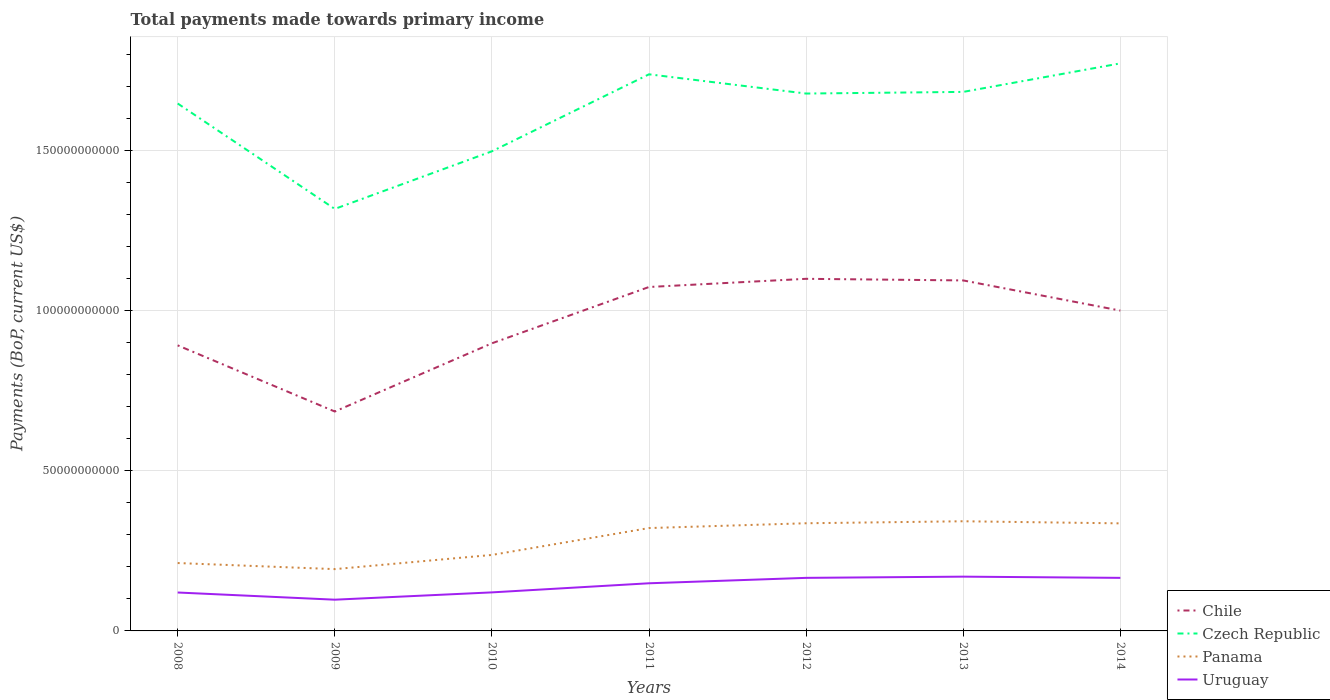How many different coloured lines are there?
Ensure brevity in your answer.  4. Is the number of lines equal to the number of legend labels?
Provide a short and direct response. Yes. Across all years, what is the maximum total payments made towards primary income in Czech Republic?
Keep it short and to the point. 1.32e+11. In which year was the total payments made towards primary income in Czech Republic maximum?
Your response must be concise. 2009. What is the total total payments made towards primary income in Panama in the graph?
Give a very brief answer. -2.53e+09. What is the difference between the highest and the second highest total payments made towards primary income in Chile?
Provide a short and direct response. 4.15e+1. How many lines are there?
Keep it short and to the point. 4. How many years are there in the graph?
Provide a short and direct response. 7. Does the graph contain any zero values?
Ensure brevity in your answer.  No. Where does the legend appear in the graph?
Give a very brief answer. Bottom right. What is the title of the graph?
Your answer should be compact. Total payments made towards primary income. Does "Bahrain" appear as one of the legend labels in the graph?
Give a very brief answer. No. What is the label or title of the Y-axis?
Your response must be concise. Payments (BoP, current US$). What is the Payments (BoP, current US$) in Chile in 2008?
Offer a terse response. 8.92e+1. What is the Payments (BoP, current US$) in Czech Republic in 2008?
Keep it short and to the point. 1.65e+11. What is the Payments (BoP, current US$) in Panama in 2008?
Keep it short and to the point. 2.12e+1. What is the Payments (BoP, current US$) in Uruguay in 2008?
Provide a succinct answer. 1.20e+1. What is the Payments (BoP, current US$) in Chile in 2009?
Provide a short and direct response. 6.86e+1. What is the Payments (BoP, current US$) in Czech Republic in 2009?
Offer a terse response. 1.32e+11. What is the Payments (BoP, current US$) in Panama in 2009?
Offer a very short reply. 1.93e+1. What is the Payments (BoP, current US$) of Uruguay in 2009?
Give a very brief answer. 9.76e+09. What is the Payments (BoP, current US$) of Chile in 2010?
Your answer should be compact. 8.99e+1. What is the Payments (BoP, current US$) of Czech Republic in 2010?
Your answer should be compact. 1.50e+11. What is the Payments (BoP, current US$) in Panama in 2010?
Your response must be concise. 2.37e+1. What is the Payments (BoP, current US$) in Uruguay in 2010?
Provide a short and direct response. 1.20e+1. What is the Payments (BoP, current US$) in Chile in 2011?
Provide a short and direct response. 1.07e+11. What is the Payments (BoP, current US$) of Czech Republic in 2011?
Offer a very short reply. 1.74e+11. What is the Payments (BoP, current US$) in Panama in 2011?
Offer a very short reply. 3.21e+1. What is the Payments (BoP, current US$) of Uruguay in 2011?
Provide a short and direct response. 1.49e+1. What is the Payments (BoP, current US$) of Chile in 2012?
Provide a succinct answer. 1.10e+11. What is the Payments (BoP, current US$) of Czech Republic in 2012?
Give a very brief answer. 1.68e+11. What is the Payments (BoP, current US$) in Panama in 2012?
Offer a very short reply. 3.36e+1. What is the Payments (BoP, current US$) in Uruguay in 2012?
Offer a terse response. 1.66e+1. What is the Payments (BoP, current US$) in Chile in 2013?
Make the answer very short. 1.10e+11. What is the Payments (BoP, current US$) in Czech Republic in 2013?
Provide a succinct answer. 1.68e+11. What is the Payments (BoP, current US$) of Panama in 2013?
Make the answer very short. 3.43e+1. What is the Payments (BoP, current US$) in Uruguay in 2013?
Ensure brevity in your answer.  1.70e+1. What is the Payments (BoP, current US$) of Chile in 2014?
Keep it short and to the point. 1.00e+11. What is the Payments (BoP, current US$) of Czech Republic in 2014?
Your answer should be very brief. 1.77e+11. What is the Payments (BoP, current US$) in Panama in 2014?
Your answer should be very brief. 3.36e+1. What is the Payments (BoP, current US$) in Uruguay in 2014?
Your response must be concise. 1.66e+1. Across all years, what is the maximum Payments (BoP, current US$) of Chile?
Provide a succinct answer. 1.10e+11. Across all years, what is the maximum Payments (BoP, current US$) in Czech Republic?
Make the answer very short. 1.77e+11. Across all years, what is the maximum Payments (BoP, current US$) of Panama?
Your response must be concise. 3.43e+1. Across all years, what is the maximum Payments (BoP, current US$) of Uruguay?
Your response must be concise. 1.70e+1. Across all years, what is the minimum Payments (BoP, current US$) in Chile?
Give a very brief answer. 6.86e+1. Across all years, what is the minimum Payments (BoP, current US$) of Czech Republic?
Provide a short and direct response. 1.32e+11. Across all years, what is the minimum Payments (BoP, current US$) in Panama?
Your response must be concise. 1.93e+1. Across all years, what is the minimum Payments (BoP, current US$) in Uruguay?
Keep it short and to the point. 9.76e+09. What is the total Payments (BoP, current US$) in Chile in the graph?
Make the answer very short. 6.75e+11. What is the total Payments (BoP, current US$) of Czech Republic in the graph?
Provide a succinct answer. 1.13e+12. What is the total Payments (BoP, current US$) in Panama in the graph?
Your response must be concise. 1.98e+11. What is the total Payments (BoP, current US$) in Uruguay in the graph?
Your answer should be compact. 9.88e+1. What is the difference between the Payments (BoP, current US$) in Chile in 2008 and that in 2009?
Keep it short and to the point. 2.07e+1. What is the difference between the Payments (BoP, current US$) of Czech Republic in 2008 and that in 2009?
Your answer should be compact. 3.29e+1. What is the difference between the Payments (BoP, current US$) of Panama in 2008 and that in 2009?
Keep it short and to the point. 1.90e+09. What is the difference between the Payments (BoP, current US$) in Uruguay in 2008 and that in 2009?
Your answer should be compact. 2.24e+09. What is the difference between the Payments (BoP, current US$) in Chile in 2008 and that in 2010?
Offer a terse response. -6.36e+08. What is the difference between the Payments (BoP, current US$) in Czech Republic in 2008 and that in 2010?
Give a very brief answer. 1.49e+1. What is the difference between the Payments (BoP, current US$) in Panama in 2008 and that in 2010?
Keep it short and to the point. -2.53e+09. What is the difference between the Payments (BoP, current US$) of Uruguay in 2008 and that in 2010?
Your answer should be compact. -3.72e+07. What is the difference between the Payments (BoP, current US$) of Chile in 2008 and that in 2011?
Your response must be concise. -1.82e+1. What is the difference between the Payments (BoP, current US$) of Czech Republic in 2008 and that in 2011?
Provide a short and direct response. -9.12e+09. What is the difference between the Payments (BoP, current US$) in Panama in 2008 and that in 2011?
Offer a terse response. -1.09e+1. What is the difference between the Payments (BoP, current US$) of Uruguay in 2008 and that in 2011?
Give a very brief answer. -2.88e+09. What is the difference between the Payments (BoP, current US$) in Chile in 2008 and that in 2012?
Offer a very short reply. -2.08e+1. What is the difference between the Payments (BoP, current US$) of Czech Republic in 2008 and that in 2012?
Your answer should be very brief. -3.11e+09. What is the difference between the Payments (BoP, current US$) of Panama in 2008 and that in 2012?
Offer a terse response. -1.24e+1. What is the difference between the Payments (BoP, current US$) of Uruguay in 2008 and that in 2012?
Ensure brevity in your answer.  -4.57e+09. What is the difference between the Payments (BoP, current US$) of Chile in 2008 and that in 2013?
Your answer should be compact. -2.03e+1. What is the difference between the Payments (BoP, current US$) in Czech Republic in 2008 and that in 2013?
Your response must be concise. -3.62e+09. What is the difference between the Payments (BoP, current US$) of Panama in 2008 and that in 2013?
Provide a short and direct response. -1.31e+1. What is the difference between the Payments (BoP, current US$) of Uruguay in 2008 and that in 2013?
Keep it short and to the point. -4.95e+09. What is the difference between the Payments (BoP, current US$) of Chile in 2008 and that in 2014?
Give a very brief answer. -1.09e+1. What is the difference between the Payments (BoP, current US$) in Czech Republic in 2008 and that in 2014?
Provide a succinct answer. -1.25e+1. What is the difference between the Payments (BoP, current US$) of Panama in 2008 and that in 2014?
Provide a short and direct response. -1.24e+1. What is the difference between the Payments (BoP, current US$) of Uruguay in 2008 and that in 2014?
Offer a terse response. -4.57e+09. What is the difference between the Payments (BoP, current US$) of Chile in 2009 and that in 2010?
Provide a short and direct response. -2.13e+1. What is the difference between the Payments (BoP, current US$) in Czech Republic in 2009 and that in 2010?
Make the answer very short. -1.80e+1. What is the difference between the Payments (BoP, current US$) in Panama in 2009 and that in 2010?
Provide a succinct answer. -4.43e+09. What is the difference between the Payments (BoP, current US$) of Uruguay in 2009 and that in 2010?
Give a very brief answer. -2.28e+09. What is the difference between the Payments (BoP, current US$) of Chile in 2009 and that in 2011?
Provide a short and direct response. -3.89e+1. What is the difference between the Payments (BoP, current US$) of Czech Republic in 2009 and that in 2011?
Provide a succinct answer. -4.21e+1. What is the difference between the Payments (BoP, current US$) of Panama in 2009 and that in 2011?
Give a very brief answer. -1.28e+1. What is the difference between the Payments (BoP, current US$) in Uruguay in 2009 and that in 2011?
Provide a short and direct response. -5.13e+09. What is the difference between the Payments (BoP, current US$) of Chile in 2009 and that in 2012?
Provide a succinct answer. -4.15e+1. What is the difference between the Payments (BoP, current US$) in Czech Republic in 2009 and that in 2012?
Keep it short and to the point. -3.61e+1. What is the difference between the Payments (BoP, current US$) in Panama in 2009 and that in 2012?
Give a very brief answer. -1.43e+1. What is the difference between the Payments (BoP, current US$) of Uruguay in 2009 and that in 2012?
Your response must be concise. -6.82e+09. What is the difference between the Payments (BoP, current US$) of Chile in 2009 and that in 2013?
Give a very brief answer. -4.10e+1. What is the difference between the Payments (BoP, current US$) in Czech Republic in 2009 and that in 2013?
Provide a short and direct response. -3.66e+1. What is the difference between the Payments (BoP, current US$) in Panama in 2009 and that in 2013?
Offer a terse response. -1.50e+1. What is the difference between the Payments (BoP, current US$) in Uruguay in 2009 and that in 2013?
Your response must be concise. -7.20e+09. What is the difference between the Payments (BoP, current US$) in Chile in 2009 and that in 2014?
Keep it short and to the point. -3.15e+1. What is the difference between the Payments (BoP, current US$) in Czech Republic in 2009 and that in 2014?
Provide a short and direct response. -4.55e+1. What is the difference between the Payments (BoP, current US$) of Panama in 2009 and that in 2014?
Offer a very short reply. -1.43e+1. What is the difference between the Payments (BoP, current US$) in Uruguay in 2009 and that in 2014?
Offer a terse response. -6.82e+09. What is the difference between the Payments (BoP, current US$) of Chile in 2010 and that in 2011?
Your answer should be compact. -1.76e+1. What is the difference between the Payments (BoP, current US$) in Czech Republic in 2010 and that in 2011?
Offer a terse response. -2.41e+1. What is the difference between the Payments (BoP, current US$) in Panama in 2010 and that in 2011?
Make the answer very short. -8.40e+09. What is the difference between the Payments (BoP, current US$) in Uruguay in 2010 and that in 2011?
Give a very brief answer. -2.85e+09. What is the difference between the Payments (BoP, current US$) in Chile in 2010 and that in 2012?
Ensure brevity in your answer.  -2.02e+1. What is the difference between the Payments (BoP, current US$) in Czech Republic in 2010 and that in 2012?
Make the answer very short. -1.81e+1. What is the difference between the Payments (BoP, current US$) of Panama in 2010 and that in 2012?
Ensure brevity in your answer.  -9.90e+09. What is the difference between the Payments (BoP, current US$) in Uruguay in 2010 and that in 2012?
Offer a very short reply. -4.54e+09. What is the difference between the Payments (BoP, current US$) in Chile in 2010 and that in 2013?
Your answer should be compact. -1.97e+1. What is the difference between the Payments (BoP, current US$) in Czech Republic in 2010 and that in 2013?
Provide a short and direct response. -1.86e+1. What is the difference between the Payments (BoP, current US$) of Panama in 2010 and that in 2013?
Offer a very short reply. -1.05e+1. What is the difference between the Payments (BoP, current US$) of Uruguay in 2010 and that in 2013?
Your answer should be very brief. -4.92e+09. What is the difference between the Payments (BoP, current US$) of Chile in 2010 and that in 2014?
Your answer should be compact. -1.02e+1. What is the difference between the Payments (BoP, current US$) of Czech Republic in 2010 and that in 2014?
Give a very brief answer. -2.75e+1. What is the difference between the Payments (BoP, current US$) of Panama in 2010 and that in 2014?
Offer a terse response. -9.87e+09. What is the difference between the Payments (BoP, current US$) in Uruguay in 2010 and that in 2014?
Ensure brevity in your answer.  -4.54e+09. What is the difference between the Payments (BoP, current US$) of Chile in 2011 and that in 2012?
Make the answer very short. -2.56e+09. What is the difference between the Payments (BoP, current US$) of Czech Republic in 2011 and that in 2012?
Keep it short and to the point. 6.01e+09. What is the difference between the Payments (BoP, current US$) in Panama in 2011 and that in 2012?
Provide a short and direct response. -1.50e+09. What is the difference between the Payments (BoP, current US$) in Uruguay in 2011 and that in 2012?
Your response must be concise. -1.69e+09. What is the difference between the Payments (BoP, current US$) in Chile in 2011 and that in 2013?
Give a very brief answer. -2.05e+09. What is the difference between the Payments (BoP, current US$) of Czech Republic in 2011 and that in 2013?
Keep it short and to the point. 5.50e+09. What is the difference between the Payments (BoP, current US$) in Panama in 2011 and that in 2013?
Your answer should be compact. -2.12e+09. What is the difference between the Payments (BoP, current US$) in Uruguay in 2011 and that in 2013?
Offer a terse response. -2.07e+09. What is the difference between the Payments (BoP, current US$) of Chile in 2011 and that in 2014?
Ensure brevity in your answer.  7.37e+09. What is the difference between the Payments (BoP, current US$) of Czech Republic in 2011 and that in 2014?
Your answer should be compact. -3.41e+09. What is the difference between the Payments (BoP, current US$) in Panama in 2011 and that in 2014?
Your answer should be very brief. -1.47e+09. What is the difference between the Payments (BoP, current US$) in Uruguay in 2011 and that in 2014?
Ensure brevity in your answer.  -1.69e+09. What is the difference between the Payments (BoP, current US$) of Chile in 2012 and that in 2013?
Make the answer very short. 5.05e+08. What is the difference between the Payments (BoP, current US$) of Czech Republic in 2012 and that in 2013?
Keep it short and to the point. -5.15e+08. What is the difference between the Payments (BoP, current US$) in Panama in 2012 and that in 2013?
Ensure brevity in your answer.  -6.23e+08. What is the difference between the Payments (BoP, current US$) of Uruguay in 2012 and that in 2013?
Offer a terse response. -3.80e+08. What is the difference between the Payments (BoP, current US$) in Chile in 2012 and that in 2014?
Give a very brief answer. 9.93e+09. What is the difference between the Payments (BoP, current US$) of Czech Republic in 2012 and that in 2014?
Provide a succinct answer. -9.42e+09. What is the difference between the Payments (BoP, current US$) in Panama in 2012 and that in 2014?
Make the answer very short. 3.20e+07. What is the difference between the Payments (BoP, current US$) in Uruguay in 2012 and that in 2014?
Keep it short and to the point. -4.09e+05. What is the difference between the Payments (BoP, current US$) of Chile in 2013 and that in 2014?
Give a very brief answer. 9.43e+09. What is the difference between the Payments (BoP, current US$) in Czech Republic in 2013 and that in 2014?
Ensure brevity in your answer.  -8.91e+09. What is the difference between the Payments (BoP, current US$) of Panama in 2013 and that in 2014?
Your response must be concise. 6.55e+08. What is the difference between the Payments (BoP, current US$) in Uruguay in 2013 and that in 2014?
Keep it short and to the point. 3.80e+08. What is the difference between the Payments (BoP, current US$) in Chile in 2008 and the Payments (BoP, current US$) in Czech Republic in 2009?
Provide a succinct answer. -4.26e+1. What is the difference between the Payments (BoP, current US$) in Chile in 2008 and the Payments (BoP, current US$) in Panama in 2009?
Ensure brevity in your answer.  6.99e+1. What is the difference between the Payments (BoP, current US$) of Chile in 2008 and the Payments (BoP, current US$) of Uruguay in 2009?
Ensure brevity in your answer.  7.95e+1. What is the difference between the Payments (BoP, current US$) of Czech Republic in 2008 and the Payments (BoP, current US$) of Panama in 2009?
Ensure brevity in your answer.  1.46e+11. What is the difference between the Payments (BoP, current US$) of Czech Republic in 2008 and the Payments (BoP, current US$) of Uruguay in 2009?
Provide a short and direct response. 1.55e+11. What is the difference between the Payments (BoP, current US$) of Panama in 2008 and the Payments (BoP, current US$) of Uruguay in 2009?
Your answer should be very brief. 1.15e+1. What is the difference between the Payments (BoP, current US$) of Chile in 2008 and the Payments (BoP, current US$) of Czech Republic in 2010?
Your response must be concise. -6.06e+1. What is the difference between the Payments (BoP, current US$) of Chile in 2008 and the Payments (BoP, current US$) of Panama in 2010?
Your response must be concise. 6.55e+1. What is the difference between the Payments (BoP, current US$) in Chile in 2008 and the Payments (BoP, current US$) in Uruguay in 2010?
Offer a very short reply. 7.72e+1. What is the difference between the Payments (BoP, current US$) in Czech Republic in 2008 and the Payments (BoP, current US$) in Panama in 2010?
Keep it short and to the point. 1.41e+11. What is the difference between the Payments (BoP, current US$) of Czech Republic in 2008 and the Payments (BoP, current US$) of Uruguay in 2010?
Give a very brief answer. 1.53e+11. What is the difference between the Payments (BoP, current US$) of Panama in 2008 and the Payments (BoP, current US$) of Uruguay in 2010?
Provide a short and direct response. 9.17e+09. What is the difference between the Payments (BoP, current US$) of Chile in 2008 and the Payments (BoP, current US$) of Czech Republic in 2011?
Offer a very short reply. -8.47e+1. What is the difference between the Payments (BoP, current US$) in Chile in 2008 and the Payments (BoP, current US$) in Panama in 2011?
Give a very brief answer. 5.71e+1. What is the difference between the Payments (BoP, current US$) in Chile in 2008 and the Payments (BoP, current US$) in Uruguay in 2011?
Your answer should be compact. 7.44e+1. What is the difference between the Payments (BoP, current US$) of Czech Republic in 2008 and the Payments (BoP, current US$) of Panama in 2011?
Offer a terse response. 1.33e+11. What is the difference between the Payments (BoP, current US$) in Czech Republic in 2008 and the Payments (BoP, current US$) in Uruguay in 2011?
Offer a terse response. 1.50e+11. What is the difference between the Payments (BoP, current US$) of Panama in 2008 and the Payments (BoP, current US$) of Uruguay in 2011?
Ensure brevity in your answer.  6.33e+09. What is the difference between the Payments (BoP, current US$) in Chile in 2008 and the Payments (BoP, current US$) in Czech Republic in 2012?
Ensure brevity in your answer.  -7.87e+1. What is the difference between the Payments (BoP, current US$) of Chile in 2008 and the Payments (BoP, current US$) of Panama in 2012?
Offer a very short reply. 5.56e+1. What is the difference between the Payments (BoP, current US$) in Chile in 2008 and the Payments (BoP, current US$) in Uruguay in 2012?
Your answer should be very brief. 7.27e+1. What is the difference between the Payments (BoP, current US$) in Czech Republic in 2008 and the Payments (BoP, current US$) in Panama in 2012?
Your response must be concise. 1.31e+11. What is the difference between the Payments (BoP, current US$) in Czech Republic in 2008 and the Payments (BoP, current US$) in Uruguay in 2012?
Give a very brief answer. 1.48e+11. What is the difference between the Payments (BoP, current US$) of Panama in 2008 and the Payments (BoP, current US$) of Uruguay in 2012?
Your answer should be very brief. 4.63e+09. What is the difference between the Payments (BoP, current US$) of Chile in 2008 and the Payments (BoP, current US$) of Czech Republic in 2013?
Your answer should be compact. -7.92e+1. What is the difference between the Payments (BoP, current US$) of Chile in 2008 and the Payments (BoP, current US$) of Panama in 2013?
Your answer should be very brief. 5.50e+1. What is the difference between the Payments (BoP, current US$) in Chile in 2008 and the Payments (BoP, current US$) in Uruguay in 2013?
Offer a very short reply. 7.23e+1. What is the difference between the Payments (BoP, current US$) of Czech Republic in 2008 and the Payments (BoP, current US$) of Panama in 2013?
Ensure brevity in your answer.  1.31e+11. What is the difference between the Payments (BoP, current US$) of Czech Republic in 2008 and the Payments (BoP, current US$) of Uruguay in 2013?
Offer a very short reply. 1.48e+11. What is the difference between the Payments (BoP, current US$) in Panama in 2008 and the Payments (BoP, current US$) in Uruguay in 2013?
Provide a short and direct response. 4.25e+09. What is the difference between the Payments (BoP, current US$) in Chile in 2008 and the Payments (BoP, current US$) in Czech Republic in 2014?
Your response must be concise. -8.81e+1. What is the difference between the Payments (BoP, current US$) in Chile in 2008 and the Payments (BoP, current US$) in Panama in 2014?
Make the answer very short. 5.56e+1. What is the difference between the Payments (BoP, current US$) in Chile in 2008 and the Payments (BoP, current US$) in Uruguay in 2014?
Offer a very short reply. 7.27e+1. What is the difference between the Payments (BoP, current US$) in Czech Republic in 2008 and the Payments (BoP, current US$) in Panama in 2014?
Offer a terse response. 1.31e+11. What is the difference between the Payments (BoP, current US$) of Czech Republic in 2008 and the Payments (BoP, current US$) of Uruguay in 2014?
Ensure brevity in your answer.  1.48e+11. What is the difference between the Payments (BoP, current US$) of Panama in 2008 and the Payments (BoP, current US$) of Uruguay in 2014?
Your response must be concise. 4.63e+09. What is the difference between the Payments (BoP, current US$) of Chile in 2009 and the Payments (BoP, current US$) of Czech Republic in 2010?
Provide a short and direct response. -8.13e+1. What is the difference between the Payments (BoP, current US$) of Chile in 2009 and the Payments (BoP, current US$) of Panama in 2010?
Make the answer very short. 4.48e+1. What is the difference between the Payments (BoP, current US$) in Chile in 2009 and the Payments (BoP, current US$) in Uruguay in 2010?
Provide a succinct answer. 5.65e+1. What is the difference between the Payments (BoP, current US$) in Czech Republic in 2009 and the Payments (BoP, current US$) in Panama in 2010?
Keep it short and to the point. 1.08e+11. What is the difference between the Payments (BoP, current US$) in Czech Republic in 2009 and the Payments (BoP, current US$) in Uruguay in 2010?
Offer a terse response. 1.20e+11. What is the difference between the Payments (BoP, current US$) in Panama in 2009 and the Payments (BoP, current US$) in Uruguay in 2010?
Offer a very short reply. 7.27e+09. What is the difference between the Payments (BoP, current US$) of Chile in 2009 and the Payments (BoP, current US$) of Czech Republic in 2011?
Provide a short and direct response. -1.05e+11. What is the difference between the Payments (BoP, current US$) of Chile in 2009 and the Payments (BoP, current US$) of Panama in 2011?
Your answer should be compact. 3.64e+1. What is the difference between the Payments (BoP, current US$) in Chile in 2009 and the Payments (BoP, current US$) in Uruguay in 2011?
Keep it short and to the point. 5.37e+1. What is the difference between the Payments (BoP, current US$) in Czech Republic in 2009 and the Payments (BoP, current US$) in Panama in 2011?
Offer a very short reply. 9.97e+1. What is the difference between the Payments (BoP, current US$) in Czech Republic in 2009 and the Payments (BoP, current US$) in Uruguay in 2011?
Offer a terse response. 1.17e+11. What is the difference between the Payments (BoP, current US$) of Panama in 2009 and the Payments (BoP, current US$) of Uruguay in 2011?
Offer a terse response. 4.42e+09. What is the difference between the Payments (BoP, current US$) of Chile in 2009 and the Payments (BoP, current US$) of Czech Republic in 2012?
Keep it short and to the point. -9.94e+1. What is the difference between the Payments (BoP, current US$) of Chile in 2009 and the Payments (BoP, current US$) of Panama in 2012?
Your answer should be compact. 3.49e+1. What is the difference between the Payments (BoP, current US$) of Chile in 2009 and the Payments (BoP, current US$) of Uruguay in 2012?
Offer a terse response. 5.20e+1. What is the difference between the Payments (BoP, current US$) in Czech Republic in 2009 and the Payments (BoP, current US$) in Panama in 2012?
Provide a short and direct response. 9.82e+1. What is the difference between the Payments (BoP, current US$) of Czech Republic in 2009 and the Payments (BoP, current US$) of Uruguay in 2012?
Keep it short and to the point. 1.15e+11. What is the difference between the Payments (BoP, current US$) of Panama in 2009 and the Payments (BoP, current US$) of Uruguay in 2012?
Keep it short and to the point. 2.73e+09. What is the difference between the Payments (BoP, current US$) in Chile in 2009 and the Payments (BoP, current US$) in Czech Republic in 2013?
Keep it short and to the point. -9.99e+1. What is the difference between the Payments (BoP, current US$) in Chile in 2009 and the Payments (BoP, current US$) in Panama in 2013?
Your response must be concise. 3.43e+1. What is the difference between the Payments (BoP, current US$) in Chile in 2009 and the Payments (BoP, current US$) in Uruguay in 2013?
Give a very brief answer. 5.16e+1. What is the difference between the Payments (BoP, current US$) of Czech Republic in 2009 and the Payments (BoP, current US$) of Panama in 2013?
Keep it short and to the point. 9.76e+1. What is the difference between the Payments (BoP, current US$) in Czech Republic in 2009 and the Payments (BoP, current US$) in Uruguay in 2013?
Keep it short and to the point. 1.15e+11. What is the difference between the Payments (BoP, current US$) in Panama in 2009 and the Payments (BoP, current US$) in Uruguay in 2013?
Offer a terse response. 2.35e+09. What is the difference between the Payments (BoP, current US$) of Chile in 2009 and the Payments (BoP, current US$) of Czech Republic in 2014?
Make the answer very short. -1.09e+11. What is the difference between the Payments (BoP, current US$) in Chile in 2009 and the Payments (BoP, current US$) in Panama in 2014?
Make the answer very short. 3.50e+1. What is the difference between the Payments (BoP, current US$) in Chile in 2009 and the Payments (BoP, current US$) in Uruguay in 2014?
Provide a short and direct response. 5.20e+1. What is the difference between the Payments (BoP, current US$) in Czech Republic in 2009 and the Payments (BoP, current US$) in Panama in 2014?
Your answer should be compact. 9.83e+1. What is the difference between the Payments (BoP, current US$) of Czech Republic in 2009 and the Payments (BoP, current US$) of Uruguay in 2014?
Your answer should be compact. 1.15e+11. What is the difference between the Payments (BoP, current US$) in Panama in 2009 and the Payments (BoP, current US$) in Uruguay in 2014?
Ensure brevity in your answer.  2.73e+09. What is the difference between the Payments (BoP, current US$) in Chile in 2010 and the Payments (BoP, current US$) in Czech Republic in 2011?
Provide a succinct answer. -8.41e+1. What is the difference between the Payments (BoP, current US$) of Chile in 2010 and the Payments (BoP, current US$) of Panama in 2011?
Provide a succinct answer. 5.77e+1. What is the difference between the Payments (BoP, current US$) in Chile in 2010 and the Payments (BoP, current US$) in Uruguay in 2011?
Ensure brevity in your answer.  7.50e+1. What is the difference between the Payments (BoP, current US$) of Czech Republic in 2010 and the Payments (BoP, current US$) of Panama in 2011?
Make the answer very short. 1.18e+11. What is the difference between the Payments (BoP, current US$) in Czech Republic in 2010 and the Payments (BoP, current US$) in Uruguay in 2011?
Provide a succinct answer. 1.35e+11. What is the difference between the Payments (BoP, current US$) in Panama in 2010 and the Payments (BoP, current US$) in Uruguay in 2011?
Ensure brevity in your answer.  8.86e+09. What is the difference between the Payments (BoP, current US$) in Chile in 2010 and the Payments (BoP, current US$) in Czech Republic in 2012?
Ensure brevity in your answer.  -7.81e+1. What is the difference between the Payments (BoP, current US$) of Chile in 2010 and the Payments (BoP, current US$) of Panama in 2012?
Offer a very short reply. 5.62e+1. What is the difference between the Payments (BoP, current US$) of Chile in 2010 and the Payments (BoP, current US$) of Uruguay in 2012?
Offer a very short reply. 7.33e+1. What is the difference between the Payments (BoP, current US$) in Czech Republic in 2010 and the Payments (BoP, current US$) in Panama in 2012?
Offer a very short reply. 1.16e+11. What is the difference between the Payments (BoP, current US$) of Czech Republic in 2010 and the Payments (BoP, current US$) of Uruguay in 2012?
Keep it short and to the point. 1.33e+11. What is the difference between the Payments (BoP, current US$) of Panama in 2010 and the Payments (BoP, current US$) of Uruguay in 2012?
Keep it short and to the point. 7.17e+09. What is the difference between the Payments (BoP, current US$) of Chile in 2010 and the Payments (BoP, current US$) of Czech Republic in 2013?
Make the answer very short. -7.86e+1. What is the difference between the Payments (BoP, current US$) of Chile in 2010 and the Payments (BoP, current US$) of Panama in 2013?
Your answer should be compact. 5.56e+1. What is the difference between the Payments (BoP, current US$) of Chile in 2010 and the Payments (BoP, current US$) of Uruguay in 2013?
Give a very brief answer. 7.29e+1. What is the difference between the Payments (BoP, current US$) of Czech Republic in 2010 and the Payments (BoP, current US$) of Panama in 2013?
Make the answer very short. 1.16e+11. What is the difference between the Payments (BoP, current US$) in Czech Republic in 2010 and the Payments (BoP, current US$) in Uruguay in 2013?
Your answer should be very brief. 1.33e+11. What is the difference between the Payments (BoP, current US$) of Panama in 2010 and the Payments (BoP, current US$) of Uruguay in 2013?
Ensure brevity in your answer.  6.79e+09. What is the difference between the Payments (BoP, current US$) in Chile in 2010 and the Payments (BoP, current US$) in Czech Republic in 2014?
Your answer should be compact. -8.75e+1. What is the difference between the Payments (BoP, current US$) of Chile in 2010 and the Payments (BoP, current US$) of Panama in 2014?
Offer a terse response. 5.63e+1. What is the difference between the Payments (BoP, current US$) in Chile in 2010 and the Payments (BoP, current US$) in Uruguay in 2014?
Your answer should be compact. 7.33e+1. What is the difference between the Payments (BoP, current US$) of Czech Republic in 2010 and the Payments (BoP, current US$) of Panama in 2014?
Your answer should be compact. 1.16e+11. What is the difference between the Payments (BoP, current US$) of Czech Republic in 2010 and the Payments (BoP, current US$) of Uruguay in 2014?
Your answer should be very brief. 1.33e+11. What is the difference between the Payments (BoP, current US$) in Panama in 2010 and the Payments (BoP, current US$) in Uruguay in 2014?
Keep it short and to the point. 7.17e+09. What is the difference between the Payments (BoP, current US$) of Chile in 2011 and the Payments (BoP, current US$) of Czech Republic in 2012?
Keep it short and to the point. -6.05e+1. What is the difference between the Payments (BoP, current US$) in Chile in 2011 and the Payments (BoP, current US$) in Panama in 2012?
Offer a terse response. 7.38e+1. What is the difference between the Payments (BoP, current US$) in Chile in 2011 and the Payments (BoP, current US$) in Uruguay in 2012?
Give a very brief answer. 9.09e+1. What is the difference between the Payments (BoP, current US$) of Czech Republic in 2011 and the Payments (BoP, current US$) of Panama in 2012?
Your answer should be very brief. 1.40e+11. What is the difference between the Payments (BoP, current US$) of Czech Republic in 2011 and the Payments (BoP, current US$) of Uruguay in 2012?
Your answer should be compact. 1.57e+11. What is the difference between the Payments (BoP, current US$) in Panama in 2011 and the Payments (BoP, current US$) in Uruguay in 2012?
Keep it short and to the point. 1.56e+1. What is the difference between the Payments (BoP, current US$) of Chile in 2011 and the Payments (BoP, current US$) of Czech Republic in 2013?
Give a very brief answer. -6.10e+1. What is the difference between the Payments (BoP, current US$) in Chile in 2011 and the Payments (BoP, current US$) in Panama in 2013?
Ensure brevity in your answer.  7.32e+1. What is the difference between the Payments (BoP, current US$) in Chile in 2011 and the Payments (BoP, current US$) in Uruguay in 2013?
Offer a very short reply. 9.05e+1. What is the difference between the Payments (BoP, current US$) of Czech Republic in 2011 and the Payments (BoP, current US$) of Panama in 2013?
Keep it short and to the point. 1.40e+11. What is the difference between the Payments (BoP, current US$) of Czech Republic in 2011 and the Payments (BoP, current US$) of Uruguay in 2013?
Provide a succinct answer. 1.57e+11. What is the difference between the Payments (BoP, current US$) in Panama in 2011 and the Payments (BoP, current US$) in Uruguay in 2013?
Your answer should be very brief. 1.52e+1. What is the difference between the Payments (BoP, current US$) of Chile in 2011 and the Payments (BoP, current US$) of Czech Republic in 2014?
Offer a terse response. -6.99e+1. What is the difference between the Payments (BoP, current US$) of Chile in 2011 and the Payments (BoP, current US$) of Panama in 2014?
Make the answer very short. 7.39e+1. What is the difference between the Payments (BoP, current US$) in Chile in 2011 and the Payments (BoP, current US$) in Uruguay in 2014?
Keep it short and to the point. 9.09e+1. What is the difference between the Payments (BoP, current US$) of Czech Republic in 2011 and the Payments (BoP, current US$) of Panama in 2014?
Offer a very short reply. 1.40e+11. What is the difference between the Payments (BoP, current US$) of Czech Republic in 2011 and the Payments (BoP, current US$) of Uruguay in 2014?
Give a very brief answer. 1.57e+11. What is the difference between the Payments (BoP, current US$) of Panama in 2011 and the Payments (BoP, current US$) of Uruguay in 2014?
Offer a very short reply. 1.56e+1. What is the difference between the Payments (BoP, current US$) of Chile in 2012 and the Payments (BoP, current US$) of Czech Republic in 2013?
Offer a terse response. -5.84e+1. What is the difference between the Payments (BoP, current US$) of Chile in 2012 and the Payments (BoP, current US$) of Panama in 2013?
Provide a short and direct response. 7.58e+1. What is the difference between the Payments (BoP, current US$) of Chile in 2012 and the Payments (BoP, current US$) of Uruguay in 2013?
Provide a short and direct response. 9.31e+1. What is the difference between the Payments (BoP, current US$) of Czech Republic in 2012 and the Payments (BoP, current US$) of Panama in 2013?
Provide a short and direct response. 1.34e+11. What is the difference between the Payments (BoP, current US$) in Czech Republic in 2012 and the Payments (BoP, current US$) in Uruguay in 2013?
Provide a succinct answer. 1.51e+11. What is the difference between the Payments (BoP, current US$) in Panama in 2012 and the Payments (BoP, current US$) in Uruguay in 2013?
Provide a succinct answer. 1.67e+1. What is the difference between the Payments (BoP, current US$) of Chile in 2012 and the Payments (BoP, current US$) of Czech Republic in 2014?
Provide a succinct answer. -6.73e+1. What is the difference between the Payments (BoP, current US$) in Chile in 2012 and the Payments (BoP, current US$) in Panama in 2014?
Offer a terse response. 7.64e+1. What is the difference between the Payments (BoP, current US$) of Chile in 2012 and the Payments (BoP, current US$) of Uruguay in 2014?
Give a very brief answer. 9.35e+1. What is the difference between the Payments (BoP, current US$) in Czech Republic in 2012 and the Payments (BoP, current US$) in Panama in 2014?
Give a very brief answer. 1.34e+11. What is the difference between the Payments (BoP, current US$) in Czech Republic in 2012 and the Payments (BoP, current US$) in Uruguay in 2014?
Provide a short and direct response. 1.51e+11. What is the difference between the Payments (BoP, current US$) of Panama in 2012 and the Payments (BoP, current US$) of Uruguay in 2014?
Your answer should be compact. 1.71e+1. What is the difference between the Payments (BoP, current US$) of Chile in 2013 and the Payments (BoP, current US$) of Czech Republic in 2014?
Your answer should be very brief. -6.78e+1. What is the difference between the Payments (BoP, current US$) in Chile in 2013 and the Payments (BoP, current US$) in Panama in 2014?
Keep it short and to the point. 7.59e+1. What is the difference between the Payments (BoP, current US$) of Chile in 2013 and the Payments (BoP, current US$) of Uruguay in 2014?
Offer a very short reply. 9.30e+1. What is the difference between the Payments (BoP, current US$) of Czech Republic in 2013 and the Payments (BoP, current US$) of Panama in 2014?
Ensure brevity in your answer.  1.35e+11. What is the difference between the Payments (BoP, current US$) in Czech Republic in 2013 and the Payments (BoP, current US$) in Uruguay in 2014?
Ensure brevity in your answer.  1.52e+11. What is the difference between the Payments (BoP, current US$) of Panama in 2013 and the Payments (BoP, current US$) of Uruguay in 2014?
Provide a short and direct response. 1.77e+1. What is the average Payments (BoP, current US$) of Chile per year?
Offer a terse response. 9.64e+1. What is the average Payments (BoP, current US$) of Czech Republic per year?
Your answer should be compact. 1.62e+11. What is the average Payments (BoP, current US$) in Panama per year?
Make the answer very short. 2.83e+1. What is the average Payments (BoP, current US$) of Uruguay per year?
Give a very brief answer. 1.41e+1. In the year 2008, what is the difference between the Payments (BoP, current US$) of Chile and Payments (BoP, current US$) of Czech Republic?
Give a very brief answer. -7.56e+1. In the year 2008, what is the difference between the Payments (BoP, current US$) in Chile and Payments (BoP, current US$) in Panama?
Offer a very short reply. 6.80e+1. In the year 2008, what is the difference between the Payments (BoP, current US$) of Chile and Payments (BoP, current US$) of Uruguay?
Offer a very short reply. 7.72e+1. In the year 2008, what is the difference between the Payments (BoP, current US$) of Czech Republic and Payments (BoP, current US$) of Panama?
Give a very brief answer. 1.44e+11. In the year 2008, what is the difference between the Payments (BoP, current US$) of Czech Republic and Payments (BoP, current US$) of Uruguay?
Offer a very short reply. 1.53e+11. In the year 2008, what is the difference between the Payments (BoP, current US$) in Panama and Payments (BoP, current US$) in Uruguay?
Provide a succinct answer. 9.21e+09. In the year 2009, what is the difference between the Payments (BoP, current US$) of Chile and Payments (BoP, current US$) of Czech Republic?
Make the answer very short. -6.33e+1. In the year 2009, what is the difference between the Payments (BoP, current US$) in Chile and Payments (BoP, current US$) in Panama?
Keep it short and to the point. 4.93e+1. In the year 2009, what is the difference between the Payments (BoP, current US$) in Chile and Payments (BoP, current US$) in Uruguay?
Keep it short and to the point. 5.88e+1. In the year 2009, what is the difference between the Payments (BoP, current US$) of Czech Republic and Payments (BoP, current US$) of Panama?
Your response must be concise. 1.13e+11. In the year 2009, what is the difference between the Payments (BoP, current US$) of Czech Republic and Payments (BoP, current US$) of Uruguay?
Your answer should be compact. 1.22e+11. In the year 2009, what is the difference between the Payments (BoP, current US$) in Panama and Payments (BoP, current US$) in Uruguay?
Offer a terse response. 9.55e+09. In the year 2010, what is the difference between the Payments (BoP, current US$) in Chile and Payments (BoP, current US$) in Czech Republic?
Keep it short and to the point. -6.00e+1. In the year 2010, what is the difference between the Payments (BoP, current US$) of Chile and Payments (BoP, current US$) of Panama?
Offer a terse response. 6.61e+1. In the year 2010, what is the difference between the Payments (BoP, current US$) in Chile and Payments (BoP, current US$) in Uruguay?
Ensure brevity in your answer.  7.78e+1. In the year 2010, what is the difference between the Payments (BoP, current US$) of Czech Republic and Payments (BoP, current US$) of Panama?
Keep it short and to the point. 1.26e+11. In the year 2010, what is the difference between the Payments (BoP, current US$) in Czech Republic and Payments (BoP, current US$) in Uruguay?
Your answer should be very brief. 1.38e+11. In the year 2010, what is the difference between the Payments (BoP, current US$) of Panama and Payments (BoP, current US$) of Uruguay?
Provide a short and direct response. 1.17e+1. In the year 2011, what is the difference between the Payments (BoP, current US$) of Chile and Payments (BoP, current US$) of Czech Republic?
Provide a succinct answer. -6.65e+1. In the year 2011, what is the difference between the Payments (BoP, current US$) of Chile and Payments (BoP, current US$) of Panama?
Make the answer very short. 7.53e+1. In the year 2011, what is the difference between the Payments (BoP, current US$) in Chile and Payments (BoP, current US$) in Uruguay?
Ensure brevity in your answer.  9.26e+1. In the year 2011, what is the difference between the Payments (BoP, current US$) of Czech Republic and Payments (BoP, current US$) of Panama?
Your response must be concise. 1.42e+11. In the year 2011, what is the difference between the Payments (BoP, current US$) in Czech Republic and Payments (BoP, current US$) in Uruguay?
Provide a succinct answer. 1.59e+11. In the year 2011, what is the difference between the Payments (BoP, current US$) of Panama and Payments (BoP, current US$) of Uruguay?
Your answer should be very brief. 1.73e+1. In the year 2012, what is the difference between the Payments (BoP, current US$) in Chile and Payments (BoP, current US$) in Czech Republic?
Your answer should be compact. -5.79e+1. In the year 2012, what is the difference between the Payments (BoP, current US$) of Chile and Payments (BoP, current US$) of Panama?
Offer a very short reply. 7.64e+1. In the year 2012, what is the difference between the Payments (BoP, current US$) of Chile and Payments (BoP, current US$) of Uruguay?
Provide a short and direct response. 9.35e+1. In the year 2012, what is the difference between the Payments (BoP, current US$) of Czech Republic and Payments (BoP, current US$) of Panama?
Make the answer very short. 1.34e+11. In the year 2012, what is the difference between the Payments (BoP, current US$) in Czech Republic and Payments (BoP, current US$) in Uruguay?
Give a very brief answer. 1.51e+11. In the year 2012, what is the difference between the Payments (BoP, current US$) in Panama and Payments (BoP, current US$) in Uruguay?
Keep it short and to the point. 1.71e+1. In the year 2013, what is the difference between the Payments (BoP, current US$) in Chile and Payments (BoP, current US$) in Czech Republic?
Your answer should be compact. -5.89e+1. In the year 2013, what is the difference between the Payments (BoP, current US$) of Chile and Payments (BoP, current US$) of Panama?
Provide a succinct answer. 7.53e+1. In the year 2013, what is the difference between the Payments (BoP, current US$) in Chile and Payments (BoP, current US$) in Uruguay?
Offer a very short reply. 9.26e+1. In the year 2013, what is the difference between the Payments (BoP, current US$) of Czech Republic and Payments (BoP, current US$) of Panama?
Offer a very short reply. 1.34e+11. In the year 2013, what is the difference between the Payments (BoP, current US$) in Czech Republic and Payments (BoP, current US$) in Uruguay?
Offer a very short reply. 1.51e+11. In the year 2013, what is the difference between the Payments (BoP, current US$) in Panama and Payments (BoP, current US$) in Uruguay?
Provide a succinct answer. 1.73e+1. In the year 2014, what is the difference between the Payments (BoP, current US$) of Chile and Payments (BoP, current US$) of Czech Republic?
Provide a succinct answer. -7.73e+1. In the year 2014, what is the difference between the Payments (BoP, current US$) of Chile and Payments (BoP, current US$) of Panama?
Provide a succinct answer. 6.65e+1. In the year 2014, what is the difference between the Payments (BoP, current US$) of Chile and Payments (BoP, current US$) of Uruguay?
Make the answer very short. 8.35e+1. In the year 2014, what is the difference between the Payments (BoP, current US$) of Czech Republic and Payments (BoP, current US$) of Panama?
Keep it short and to the point. 1.44e+11. In the year 2014, what is the difference between the Payments (BoP, current US$) of Czech Republic and Payments (BoP, current US$) of Uruguay?
Provide a short and direct response. 1.61e+11. In the year 2014, what is the difference between the Payments (BoP, current US$) in Panama and Payments (BoP, current US$) in Uruguay?
Offer a terse response. 1.70e+1. What is the ratio of the Payments (BoP, current US$) of Chile in 2008 to that in 2009?
Give a very brief answer. 1.3. What is the ratio of the Payments (BoP, current US$) in Czech Republic in 2008 to that in 2009?
Your answer should be compact. 1.25. What is the ratio of the Payments (BoP, current US$) of Panama in 2008 to that in 2009?
Provide a succinct answer. 1.1. What is the ratio of the Payments (BoP, current US$) of Uruguay in 2008 to that in 2009?
Your answer should be very brief. 1.23. What is the ratio of the Payments (BoP, current US$) in Czech Republic in 2008 to that in 2010?
Make the answer very short. 1.1. What is the ratio of the Payments (BoP, current US$) of Panama in 2008 to that in 2010?
Provide a succinct answer. 0.89. What is the ratio of the Payments (BoP, current US$) in Uruguay in 2008 to that in 2010?
Make the answer very short. 1. What is the ratio of the Payments (BoP, current US$) in Chile in 2008 to that in 2011?
Provide a short and direct response. 0.83. What is the ratio of the Payments (BoP, current US$) in Czech Republic in 2008 to that in 2011?
Ensure brevity in your answer.  0.95. What is the ratio of the Payments (BoP, current US$) of Panama in 2008 to that in 2011?
Offer a very short reply. 0.66. What is the ratio of the Payments (BoP, current US$) in Uruguay in 2008 to that in 2011?
Ensure brevity in your answer.  0.81. What is the ratio of the Payments (BoP, current US$) of Chile in 2008 to that in 2012?
Your answer should be compact. 0.81. What is the ratio of the Payments (BoP, current US$) in Czech Republic in 2008 to that in 2012?
Offer a terse response. 0.98. What is the ratio of the Payments (BoP, current US$) in Panama in 2008 to that in 2012?
Offer a terse response. 0.63. What is the ratio of the Payments (BoP, current US$) in Uruguay in 2008 to that in 2012?
Keep it short and to the point. 0.72. What is the ratio of the Payments (BoP, current US$) in Chile in 2008 to that in 2013?
Offer a very short reply. 0.81. What is the ratio of the Payments (BoP, current US$) in Czech Republic in 2008 to that in 2013?
Provide a succinct answer. 0.98. What is the ratio of the Payments (BoP, current US$) of Panama in 2008 to that in 2013?
Provide a short and direct response. 0.62. What is the ratio of the Payments (BoP, current US$) in Uruguay in 2008 to that in 2013?
Your answer should be very brief. 0.71. What is the ratio of the Payments (BoP, current US$) in Chile in 2008 to that in 2014?
Offer a very short reply. 0.89. What is the ratio of the Payments (BoP, current US$) in Czech Republic in 2008 to that in 2014?
Offer a very short reply. 0.93. What is the ratio of the Payments (BoP, current US$) of Panama in 2008 to that in 2014?
Provide a succinct answer. 0.63. What is the ratio of the Payments (BoP, current US$) in Uruguay in 2008 to that in 2014?
Your response must be concise. 0.72. What is the ratio of the Payments (BoP, current US$) in Chile in 2009 to that in 2010?
Make the answer very short. 0.76. What is the ratio of the Payments (BoP, current US$) in Czech Republic in 2009 to that in 2010?
Ensure brevity in your answer.  0.88. What is the ratio of the Payments (BoP, current US$) in Panama in 2009 to that in 2010?
Provide a short and direct response. 0.81. What is the ratio of the Payments (BoP, current US$) of Uruguay in 2009 to that in 2010?
Give a very brief answer. 0.81. What is the ratio of the Payments (BoP, current US$) in Chile in 2009 to that in 2011?
Your response must be concise. 0.64. What is the ratio of the Payments (BoP, current US$) in Czech Republic in 2009 to that in 2011?
Provide a succinct answer. 0.76. What is the ratio of the Payments (BoP, current US$) of Panama in 2009 to that in 2011?
Your answer should be compact. 0.6. What is the ratio of the Payments (BoP, current US$) of Uruguay in 2009 to that in 2011?
Provide a succinct answer. 0.66. What is the ratio of the Payments (BoP, current US$) of Chile in 2009 to that in 2012?
Provide a succinct answer. 0.62. What is the ratio of the Payments (BoP, current US$) of Czech Republic in 2009 to that in 2012?
Offer a very short reply. 0.79. What is the ratio of the Payments (BoP, current US$) of Panama in 2009 to that in 2012?
Your answer should be compact. 0.57. What is the ratio of the Payments (BoP, current US$) in Uruguay in 2009 to that in 2012?
Provide a succinct answer. 0.59. What is the ratio of the Payments (BoP, current US$) in Chile in 2009 to that in 2013?
Your answer should be very brief. 0.63. What is the ratio of the Payments (BoP, current US$) in Czech Republic in 2009 to that in 2013?
Offer a very short reply. 0.78. What is the ratio of the Payments (BoP, current US$) in Panama in 2009 to that in 2013?
Ensure brevity in your answer.  0.56. What is the ratio of the Payments (BoP, current US$) in Uruguay in 2009 to that in 2013?
Keep it short and to the point. 0.58. What is the ratio of the Payments (BoP, current US$) of Chile in 2009 to that in 2014?
Your answer should be compact. 0.69. What is the ratio of the Payments (BoP, current US$) in Czech Republic in 2009 to that in 2014?
Ensure brevity in your answer.  0.74. What is the ratio of the Payments (BoP, current US$) of Panama in 2009 to that in 2014?
Ensure brevity in your answer.  0.57. What is the ratio of the Payments (BoP, current US$) in Uruguay in 2009 to that in 2014?
Keep it short and to the point. 0.59. What is the ratio of the Payments (BoP, current US$) of Chile in 2010 to that in 2011?
Ensure brevity in your answer.  0.84. What is the ratio of the Payments (BoP, current US$) of Czech Republic in 2010 to that in 2011?
Offer a very short reply. 0.86. What is the ratio of the Payments (BoP, current US$) in Panama in 2010 to that in 2011?
Make the answer very short. 0.74. What is the ratio of the Payments (BoP, current US$) in Uruguay in 2010 to that in 2011?
Your response must be concise. 0.81. What is the ratio of the Payments (BoP, current US$) of Chile in 2010 to that in 2012?
Your answer should be very brief. 0.82. What is the ratio of the Payments (BoP, current US$) in Czech Republic in 2010 to that in 2012?
Your answer should be very brief. 0.89. What is the ratio of the Payments (BoP, current US$) of Panama in 2010 to that in 2012?
Provide a short and direct response. 0.71. What is the ratio of the Payments (BoP, current US$) of Uruguay in 2010 to that in 2012?
Your answer should be compact. 0.73. What is the ratio of the Payments (BoP, current US$) in Chile in 2010 to that in 2013?
Offer a very short reply. 0.82. What is the ratio of the Payments (BoP, current US$) of Czech Republic in 2010 to that in 2013?
Give a very brief answer. 0.89. What is the ratio of the Payments (BoP, current US$) in Panama in 2010 to that in 2013?
Provide a succinct answer. 0.69. What is the ratio of the Payments (BoP, current US$) of Uruguay in 2010 to that in 2013?
Your response must be concise. 0.71. What is the ratio of the Payments (BoP, current US$) of Chile in 2010 to that in 2014?
Give a very brief answer. 0.9. What is the ratio of the Payments (BoP, current US$) of Czech Republic in 2010 to that in 2014?
Your answer should be very brief. 0.85. What is the ratio of the Payments (BoP, current US$) in Panama in 2010 to that in 2014?
Your answer should be very brief. 0.71. What is the ratio of the Payments (BoP, current US$) in Uruguay in 2010 to that in 2014?
Your response must be concise. 0.73. What is the ratio of the Payments (BoP, current US$) in Chile in 2011 to that in 2012?
Give a very brief answer. 0.98. What is the ratio of the Payments (BoP, current US$) of Czech Republic in 2011 to that in 2012?
Provide a succinct answer. 1.04. What is the ratio of the Payments (BoP, current US$) in Panama in 2011 to that in 2012?
Provide a short and direct response. 0.96. What is the ratio of the Payments (BoP, current US$) of Uruguay in 2011 to that in 2012?
Offer a very short reply. 0.9. What is the ratio of the Payments (BoP, current US$) of Chile in 2011 to that in 2013?
Provide a succinct answer. 0.98. What is the ratio of the Payments (BoP, current US$) in Czech Republic in 2011 to that in 2013?
Give a very brief answer. 1.03. What is the ratio of the Payments (BoP, current US$) in Panama in 2011 to that in 2013?
Keep it short and to the point. 0.94. What is the ratio of the Payments (BoP, current US$) in Uruguay in 2011 to that in 2013?
Your response must be concise. 0.88. What is the ratio of the Payments (BoP, current US$) in Chile in 2011 to that in 2014?
Your response must be concise. 1.07. What is the ratio of the Payments (BoP, current US$) in Czech Republic in 2011 to that in 2014?
Your answer should be compact. 0.98. What is the ratio of the Payments (BoP, current US$) in Panama in 2011 to that in 2014?
Your answer should be very brief. 0.96. What is the ratio of the Payments (BoP, current US$) in Uruguay in 2011 to that in 2014?
Offer a very short reply. 0.9. What is the ratio of the Payments (BoP, current US$) in Czech Republic in 2012 to that in 2013?
Your answer should be compact. 1. What is the ratio of the Payments (BoP, current US$) in Panama in 2012 to that in 2013?
Make the answer very short. 0.98. What is the ratio of the Payments (BoP, current US$) of Uruguay in 2012 to that in 2013?
Your answer should be very brief. 0.98. What is the ratio of the Payments (BoP, current US$) in Chile in 2012 to that in 2014?
Keep it short and to the point. 1.1. What is the ratio of the Payments (BoP, current US$) of Czech Republic in 2012 to that in 2014?
Provide a succinct answer. 0.95. What is the ratio of the Payments (BoP, current US$) of Uruguay in 2012 to that in 2014?
Make the answer very short. 1. What is the ratio of the Payments (BoP, current US$) in Chile in 2013 to that in 2014?
Provide a succinct answer. 1.09. What is the ratio of the Payments (BoP, current US$) of Czech Republic in 2013 to that in 2014?
Offer a terse response. 0.95. What is the ratio of the Payments (BoP, current US$) in Panama in 2013 to that in 2014?
Your answer should be very brief. 1.02. What is the ratio of the Payments (BoP, current US$) in Uruguay in 2013 to that in 2014?
Give a very brief answer. 1.02. What is the difference between the highest and the second highest Payments (BoP, current US$) in Chile?
Your answer should be compact. 5.05e+08. What is the difference between the highest and the second highest Payments (BoP, current US$) of Czech Republic?
Your answer should be very brief. 3.41e+09. What is the difference between the highest and the second highest Payments (BoP, current US$) of Panama?
Offer a very short reply. 6.23e+08. What is the difference between the highest and the second highest Payments (BoP, current US$) in Uruguay?
Your response must be concise. 3.80e+08. What is the difference between the highest and the lowest Payments (BoP, current US$) of Chile?
Offer a terse response. 4.15e+1. What is the difference between the highest and the lowest Payments (BoP, current US$) of Czech Republic?
Your answer should be very brief. 4.55e+1. What is the difference between the highest and the lowest Payments (BoP, current US$) of Panama?
Offer a terse response. 1.50e+1. What is the difference between the highest and the lowest Payments (BoP, current US$) in Uruguay?
Your answer should be compact. 7.20e+09. 